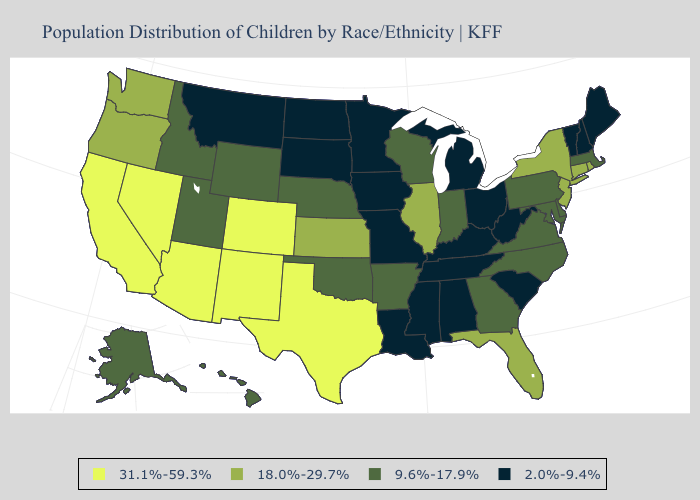Name the states that have a value in the range 2.0%-9.4%?
Write a very short answer. Alabama, Iowa, Kentucky, Louisiana, Maine, Michigan, Minnesota, Mississippi, Missouri, Montana, New Hampshire, North Dakota, Ohio, South Carolina, South Dakota, Tennessee, Vermont, West Virginia. Does Kentucky have the highest value in the South?
Be succinct. No. Name the states that have a value in the range 31.1%-59.3%?
Answer briefly. Arizona, California, Colorado, Nevada, New Mexico, Texas. What is the lowest value in states that border New Hampshire?
Answer briefly. 2.0%-9.4%. What is the value of Florida?
Concise answer only. 18.0%-29.7%. Which states have the lowest value in the USA?
Concise answer only. Alabama, Iowa, Kentucky, Louisiana, Maine, Michigan, Minnesota, Mississippi, Missouri, Montana, New Hampshire, North Dakota, Ohio, South Carolina, South Dakota, Tennessee, Vermont, West Virginia. What is the highest value in states that border Arkansas?
Be succinct. 31.1%-59.3%. Does New Hampshire have the lowest value in the Northeast?
Quick response, please. Yes. Does the map have missing data?
Be succinct. No. Does Illinois have the highest value in the MidWest?
Concise answer only. Yes. Does Illinois have the lowest value in the MidWest?
Keep it brief. No. What is the value of Wisconsin?
Keep it brief. 9.6%-17.9%. Is the legend a continuous bar?
Short answer required. No. What is the value of Utah?
Be succinct. 9.6%-17.9%. Does North Dakota have the lowest value in the MidWest?
Write a very short answer. Yes. 